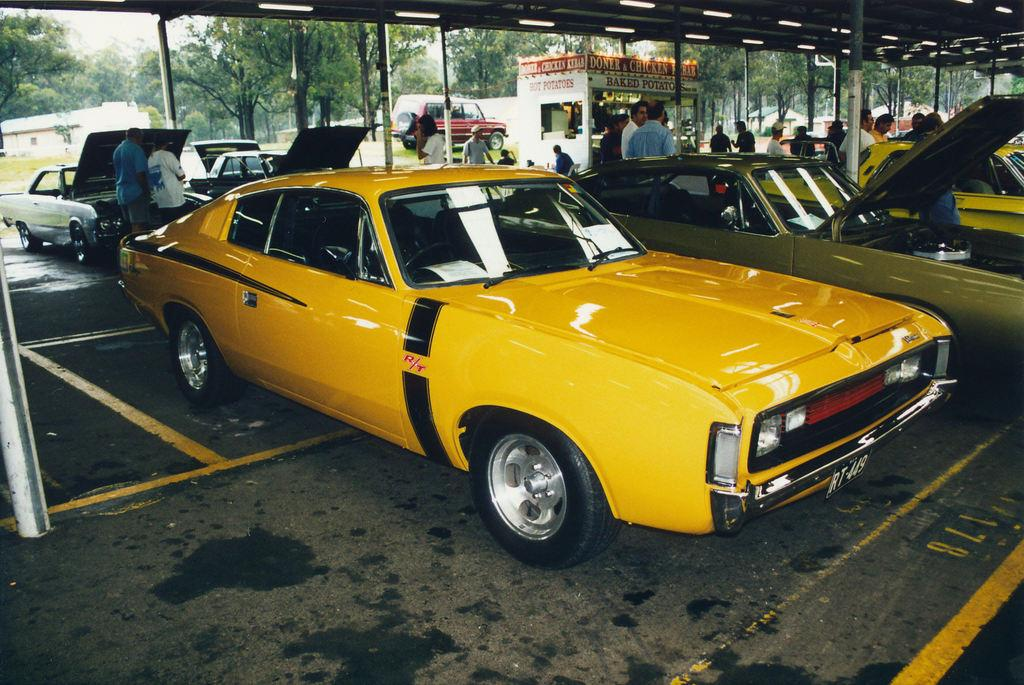<image>
Write a terse but informative summary of the picture. Yellow car with license plate RT449 at an auto show. 